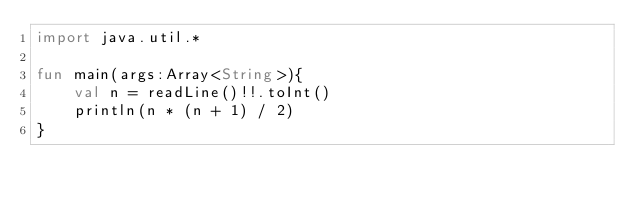<code> <loc_0><loc_0><loc_500><loc_500><_Kotlin_>import java.util.*

fun main(args:Array<String>){
    val n = readLine()!!.toInt()
    println(n * (n + 1) / 2)
}
</code> 